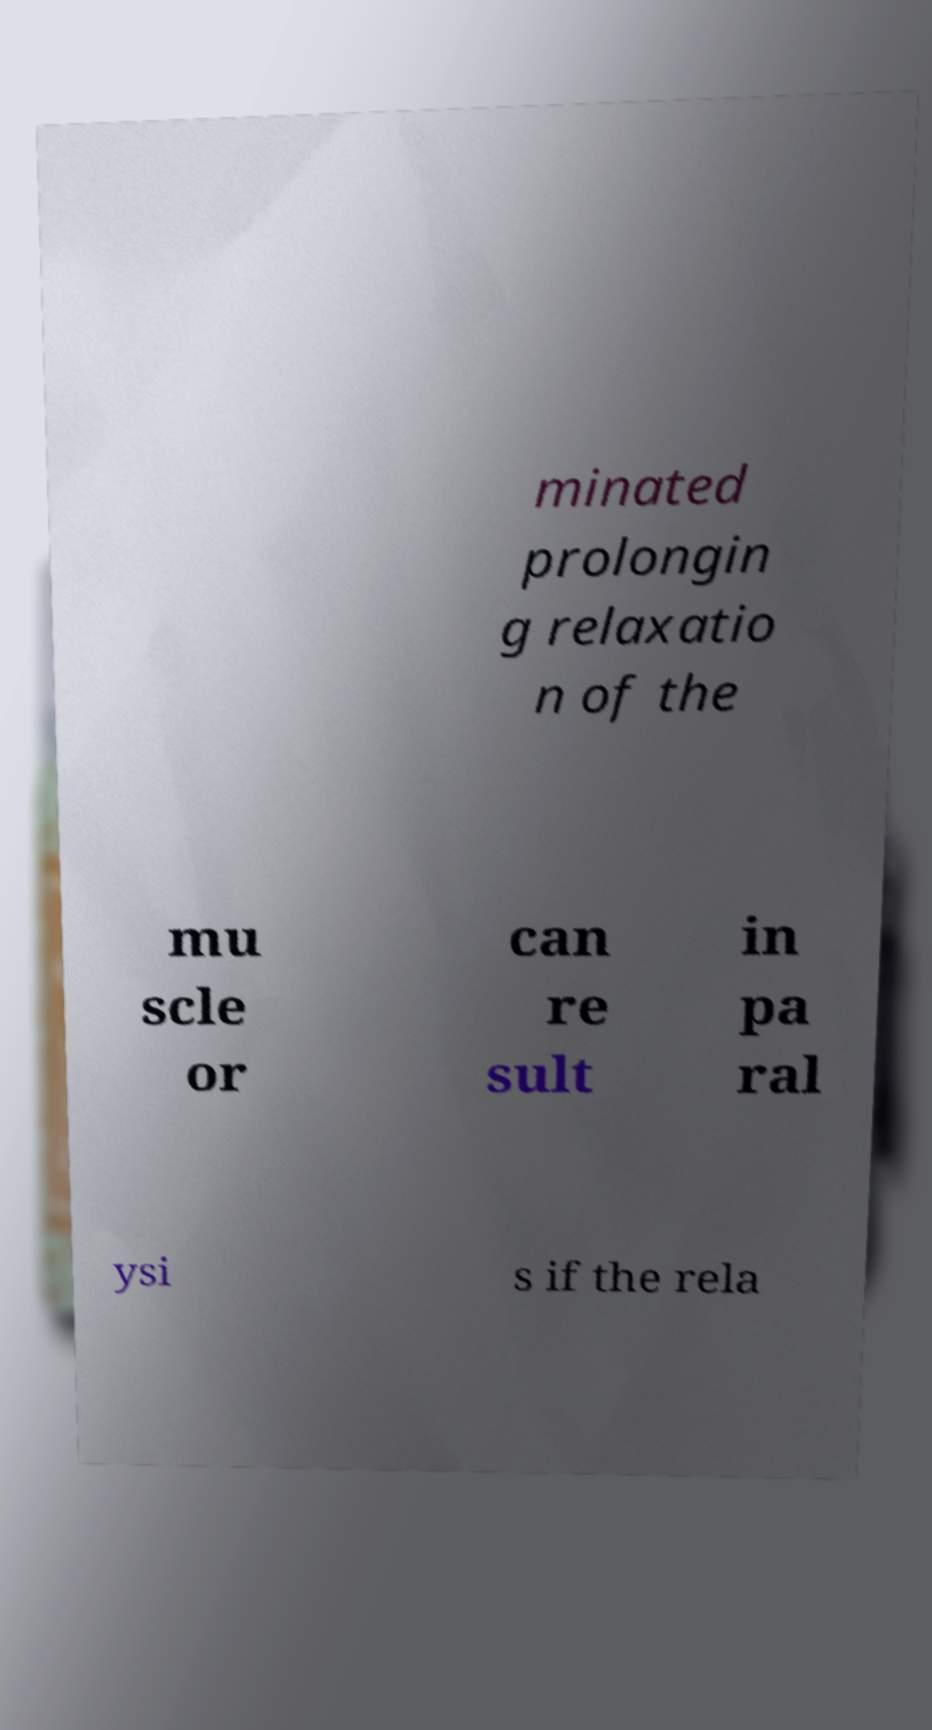There's text embedded in this image that I need extracted. Can you transcribe it verbatim? minated prolongin g relaxatio n of the mu scle or can re sult in pa ral ysi s if the rela 